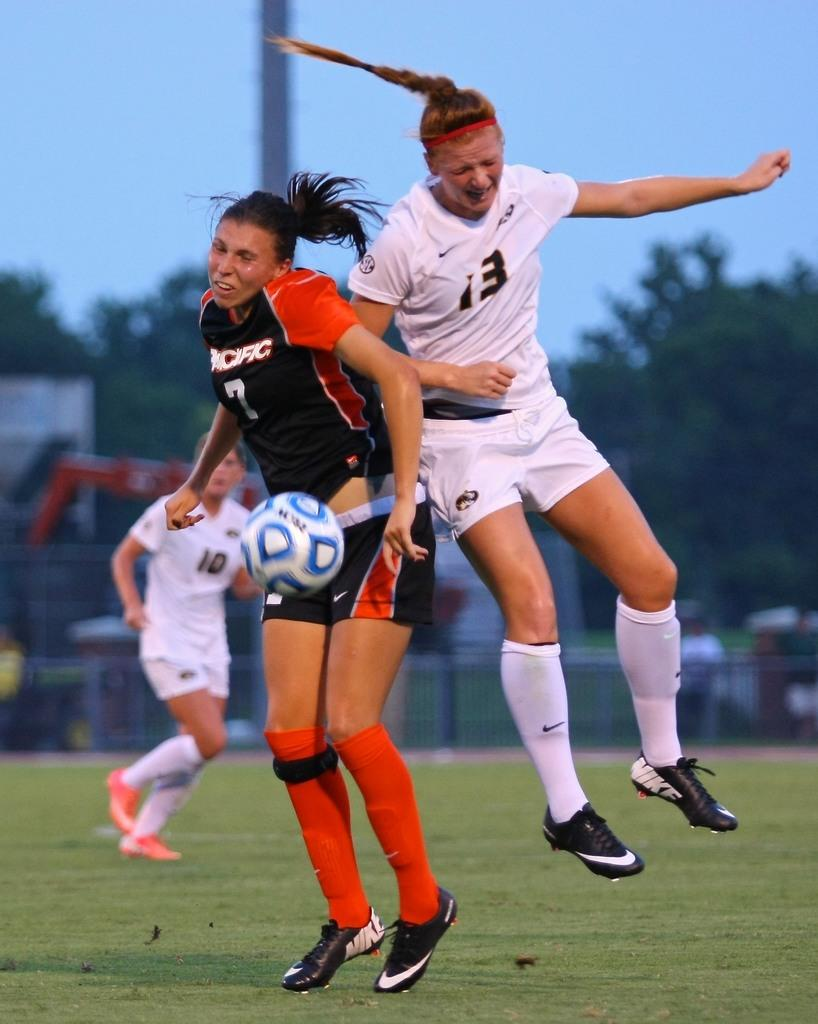<image>
Summarize the visual content of the image. girls playing soccer and one is from the pacific 